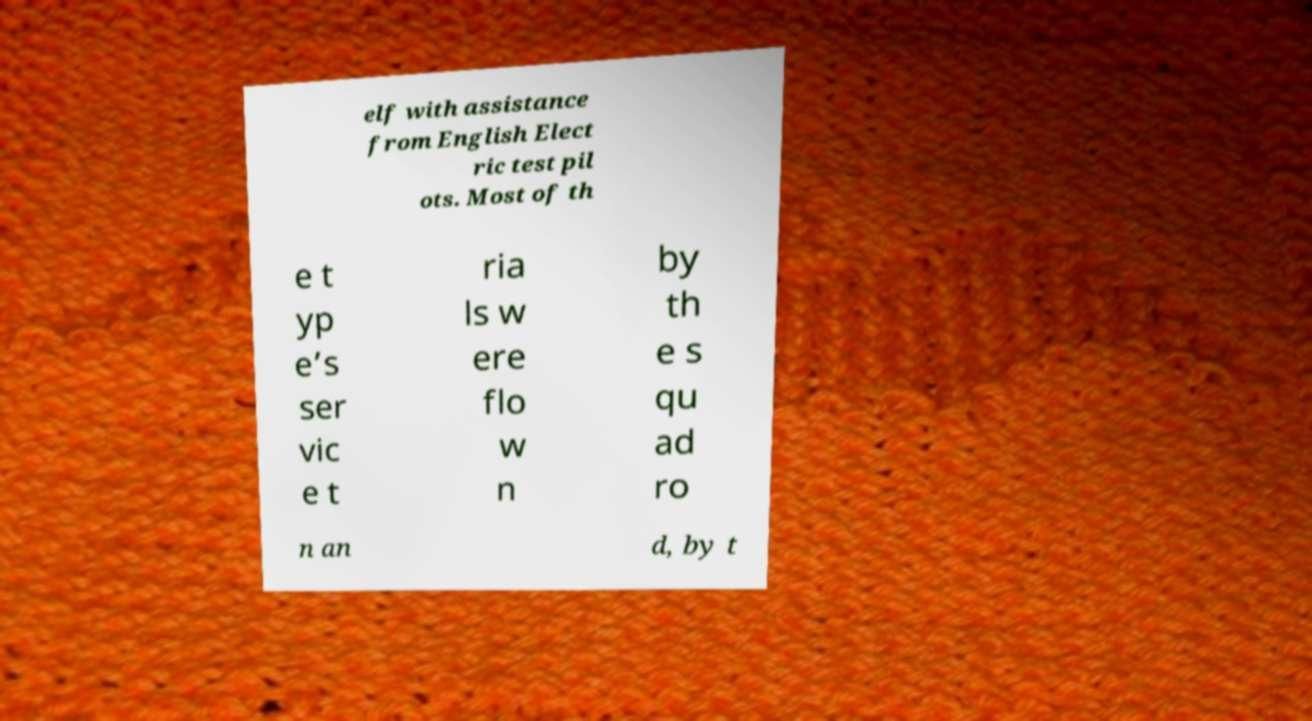Could you assist in decoding the text presented in this image and type it out clearly? elf with assistance from English Elect ric test pil ots. Most of th e t yp e’s ser vic e t ria ls w ere flo w n by th e s qu ad ro n an d, by t 